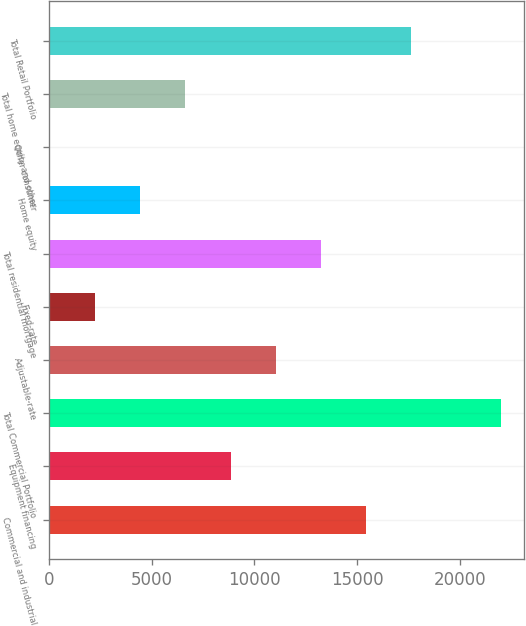Convert chart. <chart><loc_0><loc_0><loc_500><loc_500><bar_chart><fcel>Commercial and industrial<fcel>Equipment financing<fcel>Total Commercial Portfolio<fcel>Adjustable-rate<fcel>Fixed-rate<fcel>Total residential mortgage<fcel>Home equity<fcel>Other consumer<fcel>Total home equity and other<fcel>Total Retail Portfolio<nl><fcel>15432.8<fcel>8837.08<fcel>22028.5<fcel>11035.6<fcel>2241.37<fcel>13234.2<fcel>4439.94<fcel>42.8<fcel>6638.51<fcel>17631.4<nl></chart> 